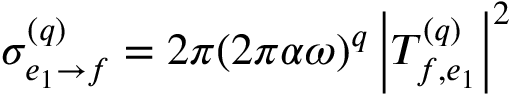<formula> <loc_0><loc_0><loc_500><loc_500>\begin{array} { r } { \sigma _ { e _ { 1 } \rightarrow f } ^ { ( q ) } = 2 \pi ( 2 \pi \alpha \omega ) ^ { q } \left | T _ { f , e _ { 1 } } ^ { ( q ) } \right | ^ { 2 } } \end{array}</formula> 